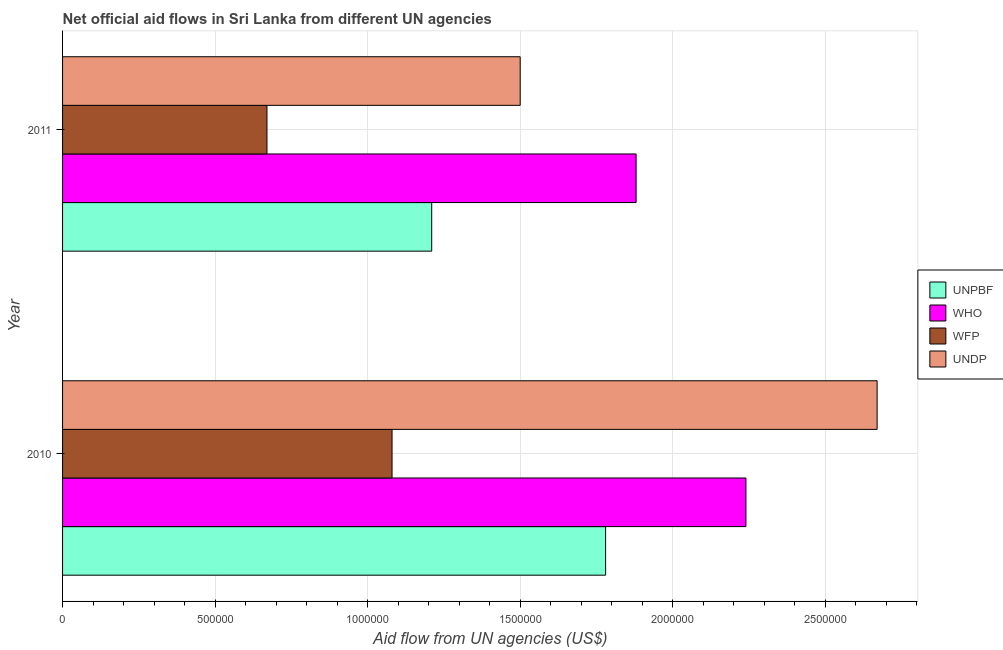How many different coloured bars are there?
Your answer should be very brief. 4. Are the number of bars per tick equal to the number of legend labels?
Your answer should be very brief. Yes. Are the number of bars on each tick of the Y-axis equal?
Make the answer very short. Yes. How many bars are there on the 2nd tick from the top?
Make the answer very short. 4. How many bars are there on the 1st tick from the bottom?
Provide a short and direct response. 4. What is the label of the 1st group of bars from the top?
Your answer should be very brief. 2011. What is the amount of aid given by who in 2010?
Your answer should be very brief. 2.24e+06. Across all years, what is the maximum amount of aid given by wfp?
Your answer should be compact. 1.08e+06. Across all years, what is the minimum amount of aid given by unpbf?
Offer a terse response. 1.21e+06. In which year was the amount of aid given by undp minimum?
Offer a terse response. 2011. What is the total amount of aid given by who in the graph?
Ensure brevity in your answer.  4.12e+06. What is the difference between the amount of aid given by who in 2010 and that in 2011?
Make the answer very short. 3.60e+05. What is the difference between the amount of aid given by undp in 2010 and the amount of aid given by wfp in 2011?
Keep it short and to the point. 2.00e+06. What is the average amount of aid given by who per year?
Keep it short and to the point. 2.06e+06. In the year 2011, what is the difference between the amount of aid given by wfp and amount of aid given by unpbf?
Offer a terse response. -5.40e+05. What is the ratio of the amount of aid given by undp in 2010 to that in 2011?
Provide a succinct answer. 1.78. In how many years, is the amount of aid given by wfp greater than the average amount of aid given by wfp taken over all years?
Ensure brevity in your answer.  1. What does the 2nd bar from the top in 2011 represents?
Offer a very short reply. WFP. What does the 1st bar from the bottom in 2011 represents?
Provide a short and direct response. UNPBF. How many bars are there?
Offer a terse response. 8. Are all the bars in the graph horizontal?
Offer a very short reply. Yes. Are the values on the major ticks of X-axis written in scientific E-notation?
Your response must be concise. No. Does the graph contain any zero values?
Give a very brief answer. No. Where does the legend appear in the graph?
Offer a terse response. Center right. How many legend labels are there?
Your response must be concise. 4. What is the title of the graph?
Offer a terse response. Net official aid flows in Sri Lanka from different UN agencies. Does "UNHCR" appear as one of the legend labels in the graph?
Your response must be concise. No. What is the label or title of the X-axis?
Offer a terse response. Aid flow from UN agencies (US$). What is the label or title of the Y-axis?
Provide a succinct answer. Year. What is the Aid flow from UN agencies (US$) in UNPBF in 2010?
Provide a short and direct response. 1.78e+06. What is the Aid flow from UN agencies (US$) of WHO in 2010?
Your answer should be compact. 2.24e+06. What is the Aid flow from UN agencies (US$) of WFP in 2010?
Ensure brevity in your answer.  1.08e+06. What is the Aid flow from UN agencies (US$) of UNDP in 2010?
Offer a very short reply. 2.67e+06. What is the Aid flow from UN agencies (US$) in UNPBF in 2011?
Your response must be concise. 1.21e+06. What is the Aid flow from UN agencies (US$) of WHO in 2011?
Provide a short and direct response. 1.88e+06. What is the Aid flow from UN agencies (US$) in WFP in 2011?
Your answer should be compact. 6.70e+05. What is the Aid flow from UN agencies (US$) of UNDP in 2011?
Your answer should be very brief. 1.50e+06. Across all years, what is the maximum Aid flow from UN agencies (US$) in UNPBF?
Your answer should be compact. 1.78e+06. Across all years, what is the maximum Aid flow from UN agencies (US$) of WHO?
Offer a very short reply. 2.24e+06. Across all years, what is the maximum Aid flow from UN agencies (US$) of WFP?
Offer a terse response. 1.08e+06. Across all years, what is the maximum Aid flow from UN agencies (US$) in UNDP?
Provide a short and direct response. 2.67e+06. Across all years, what is the minimum Aid flow from UN agencies (US$) in UNPBF?
Your response must be concise. 1.21e+06. Across all years, what is the minimum Aid flow from UN agencies (US$) in WHO?
Offer a very short reply. 1.88e+06. Across all years, what is the minimum Aid flow from UN agencies (US$) in WFP?
Offer a very short reply. 6.70e+05. Across all years, what is the minimum Aid flow from UN agencies (US$) in UNDP?
Provide a succinct answer. 1.50e+06. What is the total Aid flow from UN agencies (US$) of UNPBF in the graph?
Provide a short and direct response. 2.99e+06. What is the total Aid flow from UN agencies (US$) of WHO in the graph?
Your answer should be compact. 4.12e+06. What is the total Aid flow from UN agencies (US$) of WFP in the graph?
Keep it short and to the point. 1.75e+06. What is the total Aid flow from UN agencies (US$) in UNDP in the graph?
Keep it short and to the point. 4.17e+06. What is the difference between the Aid flow from UN agencies (US$) of UNPBF in 2010 and that in 2011?
Offer a terse response. 5.70e+05. What is the difference between the Aid flow from UN agencies (US$) of WHO in 2010 and that in 2011?
Offer a terse response. 3.60e+05. What is the difference between the Aid flow from UN agencies (US$) in WFP in 2010 and that in 2011?
Your response must be concise. 4.10e+05. What is the difference between the Aid flow from UN agencies (US$) of UNDP in 2010 and that in 2011?
Provide a succinct answer. 1.17e+06. What is the difference between the Aid flow from UN agencies (US$) of UNPBF in 2010 and the Aid flow from UN agencies (US$) of WFP in 2011?
Offer a very short reply. 1.11e+06. What is the difference between the Aid flow from UN agencies (US$) of WHO in 2010 and the Aid flow from UN agencies (US$) of WFP in 2011?
Provide a short and direct response. 1.57e+06. What is the difference between the Aid flow from UN agencies (US$) in WHO in 2010 and the Aid flow from UN agencies (US$) in UNDP in 2011?
Offer a very short reply. 7.40e+05. What is the difference between the Aid flow from UN agencies (US$) in WFP in 2010 and the Aid flow from UN agencies (US$) in UNDP in 2011?
Make the answer very short. -4.20e+05. What is the average Aid flow from UN agencies (US$) in UNPBF per year?
Your answer should be compact. 1.50e+06. What is the average Aid flow from UN agencies (US$) of WHO per year?
Ensure brevity in your answer.  2.06e+06. What is the average Aid flow from UN agencies (US$) of WFP per year?
Your response must be concise. 8.75e+05. What is the average Aid flow from UN agencies (US$) in UNDP per year?
Make the answer very short. 2.08e+06. In the year 2010, what is the difference between the Aid flow from UN agencies (US$) of UNPBF and Aid flow from UN agencies (US$) of WHO?
Your answer should be compact. -4.60e+05. In the year 2010, what is the difference between the Aid flow from UN agencies (US$) in UNPBF and Aid flow from UN agencies (US$) in WFP?
Your response must be concise. 7.00e+05. In the year 2010, what is the difference between the Aid flow from UN agencies (US$) in UNPBF and Aid flow from UN agencies (US$) in UNDP?
Your answer should be very brief. -8.90e+05. In the year 2010, what is the difference between the Aid flow from UN agencies (US$) of WHO and Aid flow from UN agencies (US$) of WFP?
Offer a very short reply. 1.16e+06. In the year 2010, what is the difference between the Aid flow from UN agencies (US$) of WHO and Aid flow from UN agencies (US$) of UNDP?
Give a very brief answer. -4.30e+05. In the year 2010, what is the difference between the Aid flow from UN agencies (US$) in WFP and Aid flow from UN agencies (US$) in UNDP?
Your answer should be very brief. -1.59e+06. In the year 2011, what is the difference between the Aid flow from UN agencies (US$) of UNPBF and Aid flow from UN agencies (US$) of WHO?
Make the answer very short. -6.70e+05. In the year 2011, what is the difference between the Aid flow from UN agencies (US$) in UNPBF and Aid flow from UN agencies (US$) in WFP?
Offer a very short reply. 5.40e+05. In the year 2011, what is the difference between the Aid flow from UN agencies (US$) in WHO and Aid flow from UN agencies (US$) in WFP?
Your answer should be compact. 1.21e+06. In the year 2011, what is the difference between the Aid flow from UN agencies (US$) of WFP and Aid flow from UN agencies (US$) of UNDP?
Your answer should be very brief. -8.30e+05. What is the ratio of the Aid flow from UN agencies (US$) of UNPBF in 2010 to that in 2011?
Provide a succinct answer. 1.47. What is the ratio of the Aid flow from UN agencies (US$) of WHO in 2010 to that in 2011?
Give a very brief answer. 1.19. What is the ratio of the Aid flow from UN agencies (US$) in WFP in 2010 to that in 2011?
Make the answer very short. 1.61. What is the ratio of the Aid flow from UN agencies (US$) of UNDP in 2010 to that in 2011?
Provide a succinct answer. 1.78. What is the difference between the highest and the second highest Aid flow from UN agencies (US$) in UNPBF?
Your response must be concise. 5.70e+05. What is the difference between the highest and the second highest Aid flow from UN agencies (US$) of WHO?
Offer a terse response. 3.60e+05. What is the difference between the highest and the second highest Aid flow from UN agencies (US$) of UNDP?
Offer a terse response. 1.17e+06. What is the difference between the highest and the lowest Aid flow from UN agencies (US$) of UNPBF?
Provide a succinct answer. 5.70e+05. What is the difference between the highest and the lowest Aid flow from UN agencies (US$) of WHO?
Your answer should be compact. 3.60e+05. What is the difference between the highest and the lowest Aid flow from UN agencies (US$) of UNDP?
Keep it short and to the point. 1.17e+06. 